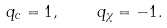<formula> <loc_0><loc_0><loc_500><loc_500>q _ { c } = 1 , \quad q _ { \chi } = - 1 .</formula> 